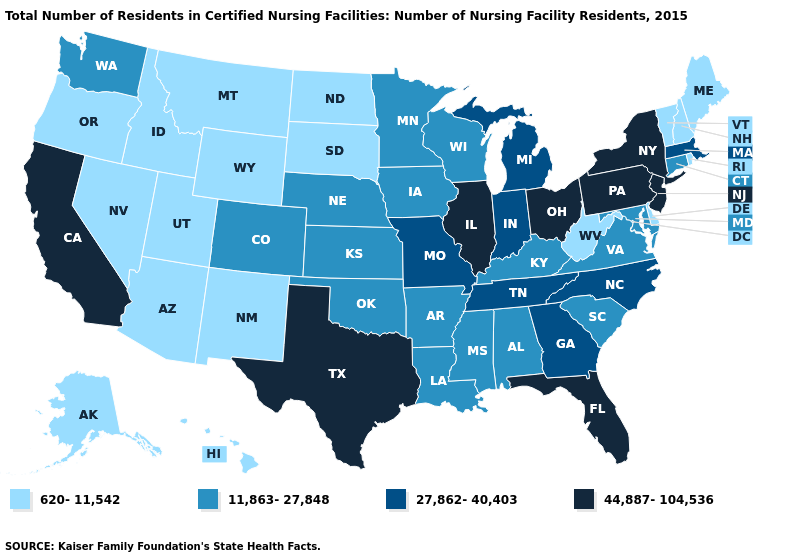What is the lowest value in the South?
Quick response, please. 620-11,542. Which states have the highest value in the USA?
Write a very short answer. California, Florida, Illinois, New Jersey, New York, Ohio, Pennsylvania, Texas. What is the highest value in states that border New York?
Give a very brief answer. 44,887-104,536. Name the states that have a value in the range 44,887-104,536?
Give a very brief answer. California, Florida, Illinois, New Jersey, New York, Ohio, Pennsylvania, Texas. Does Florida have a higher value than New York?
Give a very brief answer. No. Name the states that have a value in the range 27,862-40,403?
Keep it brief. Georgia, Indiana, Massachusetts, Michigan, Missouri, North Carolina, Tennessee. What is the value of Indiana?
Write a very short answer. 27,862-40,403. Does Delaware have the lowest value in the South?
Give a very brief answer. Yes. Name the states that have a value in the range 620-11,542?
Concise answer only. Alaska, Arizona, Delaware, Hawaii, Idaho, Maine, Montana, Nevada, New Hampshire, New Mexico, North Dakota, Oregon, Rhode Island, South Dakota, Utah, Vermont, West Virginia, Wyoming. What is the highest value in the USA?
Write a very short answer. 44,887-104,536. What is the lowest value in the South?
Quick response, please. 620-11,542. What is the value of Nebraska?
Keep it brief. 11,863-27,848. What is the value of Arizona?
Write a very short answer. 620-11,542. What is the value of Arkansas?
Short answer required. 11,863-27,848. Among the states that border Wisconsin , which have the highest value?
Be succinct. Illinois. 